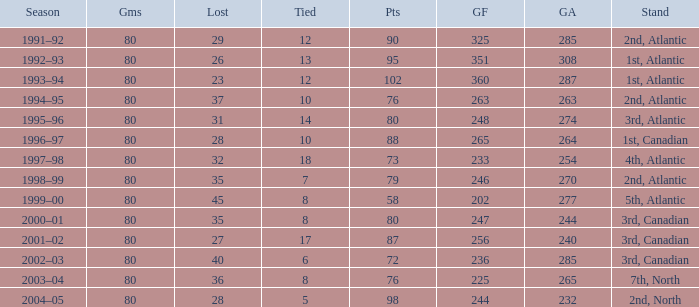Help me parse the entirety of this table. {'header': ['Season', 'Gms', 'Lost', 'Tied', 'Pts', 'GF', 'GA', 'Stand'], 'rows': [['1991–92', '80', '29', '12', '90', '325', '285', '2nd, Atlantic'], ['1992–93', '80', '26', '13', '95', '351', '308', '1st, Atlantic'], ['1993–94', '80', '23', '12', '102', '360', '287', '1st, Atlantic'], ['1994–95', '80', '37', '10', '76', '263', '263', '2nd, Atlantic'], ['1995–96', '80', '31', '14', '80', '248', '274', '3rd, Atlantic'], ['1996–97', '80', '28', '10', '88', '265', '264', '1st, Canadian'], ['1997–98', '80', '32', '18', '73', '233', '254', '4th, Atlantic'], ['1998–99', '80', '35', '7', '79', '246', '270', '2nd, Atlantic'], ['1999–00', '80', '45', '8', '58', '202', '277', '5th, Atlantic'], ['2000–01', '80', '35', '8', '80', '247', '244', '3rd, Canadian'], ['2001–02', '80', '27', '17', '87', '256', '240', '3rd, Canadian'], ['2002–03', '80', '40', '6', '72', '236', '285', '3rd, Canadian'], ['2003–04', '80', '36', '8', '76', '225', '265', '7th, North'], ['2004–05', '80', '28', '5', '98', '244', '232', '2nd, North']]} How many goals against have 58 points? 277.0. 